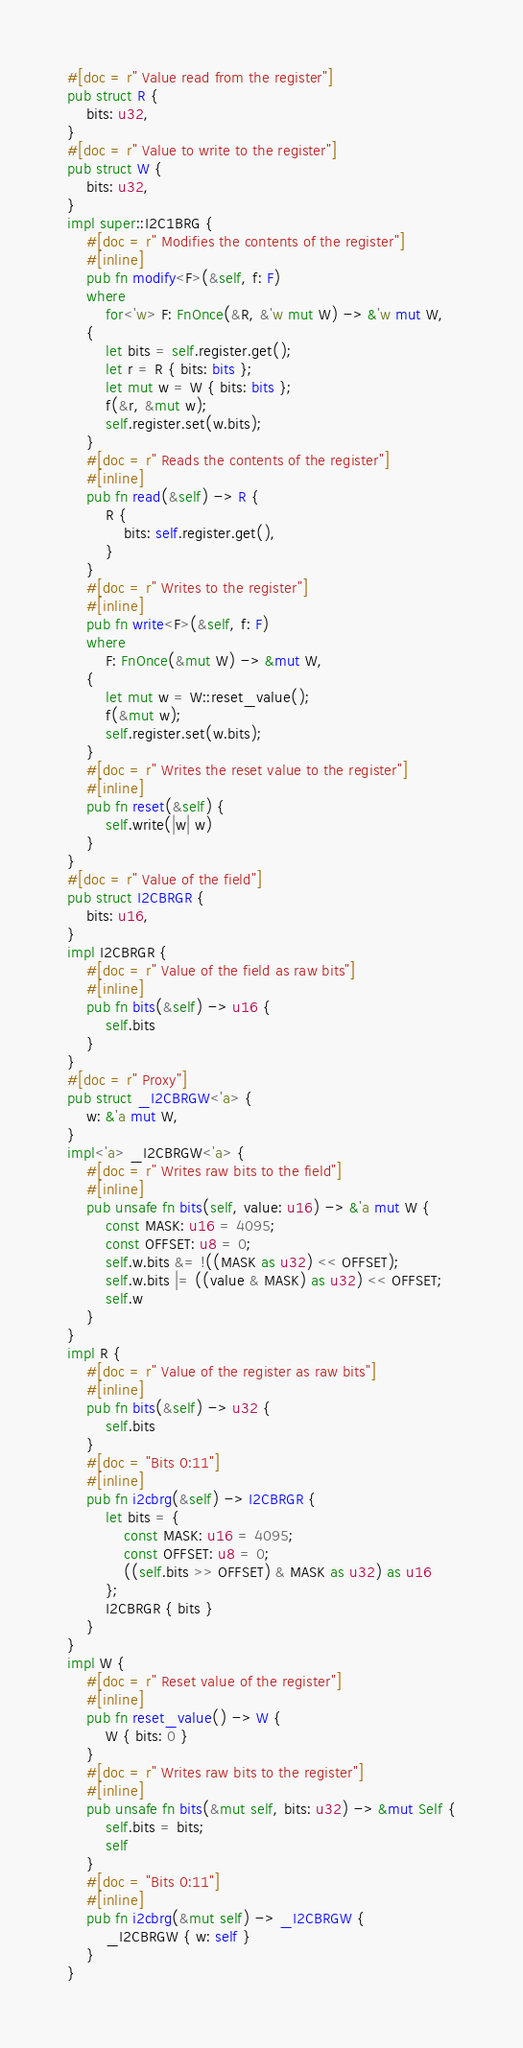Convert code to text. <code><loc_0><loc_0><loc_500><loc_500><_Rust_>#[doc = r" Value read from the register"]
pub struct R {
    bits: u32,
}
#[doc = r" Value to write to the register"]
pub struct W {
    bits: u32,
}
impl super::I2C1BRG {
    #[doc = r" Modifies the contents of the register"]
    #[inline]
    pub fn modify<F>(&self, f: F)
    where
        for<'w> F: FnOnce(&R, &'w mut W) -> &'w mut W,
    {
        let bits = self.register.get();
        let r = R { bits: bits };
        let mut w = W { bits: bits };
        f(&r, &mut w);
        self.register.set(w.bits);
    }
    #[doc = r" Reads the contents of the register"]
    #[inline]
    pub fn read(&self) -> R {
        R {
            bits: self.register.get(),
        }
    }
    #[doc = r" Writes to the register"]
    #[inline]
    pub fn write<F>(&self, f: F)
    where
        F: FnOnce(&mut W) -> &mut W,
    {
        let mut w = W::reset_value();
        f(&mut w);
        self.register.set(w.bits);
    }
    #[doc = r" Writes the reset value to the register"]
    #[inline]
    pub fn reset(&self) {
        self.write(|w| w)
    }
}
#[doc = r" Value of the field"]
pub struct I2CBRGR {
    bits: u16,
}
impl I2CBRGR {
    #[doc = r" Value of the field as raw bits"]
    #[inline]
    pub fn bits(&self) -> u16 {
        self.bits
    }
}
#[doc = r" Proxy"]
pub struct _I2CBRGW<'a> {
    w: &'a mut W,
}
impl<'a> _I2CBRGW<'a> {
    #[doc = r" Writes raw bits to the field"]
    #[inline]
    pub unsafe fn bits(self, value: u16) -> &'a mut W {
        const MASK: u16 = 4095;
        const OFFSET: u8 = 0;
        self.w.bits &= !((MASK as u32) << OFFSET);
        self.w.bits |= ((value & MASK) as u32) << OFFSET;
        self.w
    }
}
impl R {
    #[doc = r" Value of the register as raw bits"]
    #[inline]
    pub fn bits(&self) -> u32 {
        self.bits
    }
    #[doc = "Bits 0:11"]
    #[inline]
    pub fn i2cbrg(&self) -> I2CBRGR {
        let bits = {
            const MASK: u16 = 4095;
            const OFFSET: u8 = 0;
            ((self.bits >> OFFSET) & MASK as u32) as u16
        };
        I2CBRGR { bits }
    }
}
impl W {
    #[doc = r" Reset value of the register"]
    #[inline]
    pub fn reset_value() -> W {
        W { bits: 0 }
    }
    #[doc = r" Writes raw bits to the register"]
    #[inline]
    pub unsafe fn bits(&mut self, bits: u32) -> &mut Self {
        self.bits = bits;
        self
    }
    #[doc = "Bits 0:11"]
    #[inline]
    pub fn i2cbrg(&mut self) -> _I2CBRGW {
        _I2CBRGW { w: self }
    }
}
</code> 